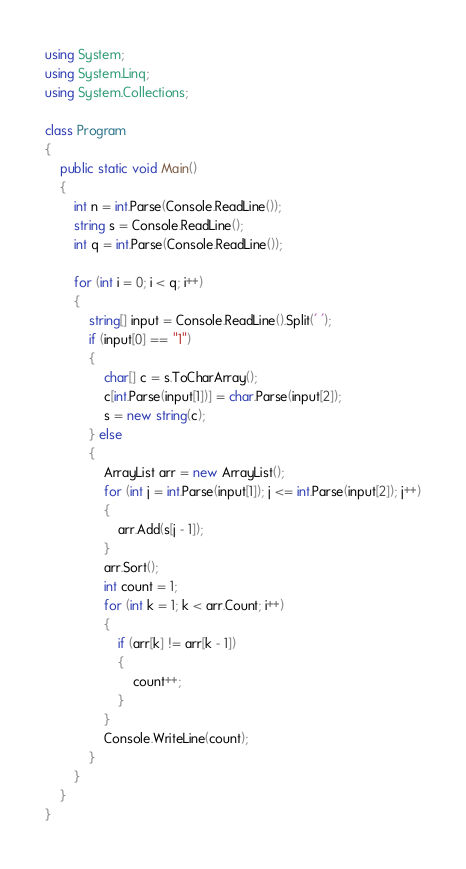Convert code to text. <code><loc_0><loc_0><loc_500><loc_500><_C#_>using System;
using System.Linq;
using System.Collections;

class Program
{
    public static void Main()
    {
        int n = int.Parse(Console.ReadLine());
        string s = Console.ReadLine();
        int q = int.Parse(Console.ReadLine());

        for (int i = 0; i < q; i++)
        {
            string[] input = Console.ReadLine().Split(' ');
            if (input[0] == "1")
            {
                char[] c = s.ToCharArray();
                c[int.Parse(input[1])] = char.Parse(input[2]);
                s = new string(c);
            } else
            {
                ArrayList arr = new ArrayList();
                for (int j = int.Parse(input[1]); j <= int.Parse(input[2]); j++)
                {
                    arr.Add(s[j - 1]);
                }
                arr.Sort();
                int count = 1;
                for (int k = 1; k < arr.Count; i++)
                {
                    if (arr[k] != arr[k - 1])
                    {
                        count++;
                    }
                }
                Console.WriteLine(count);
            }
        }
    }
}</code> 